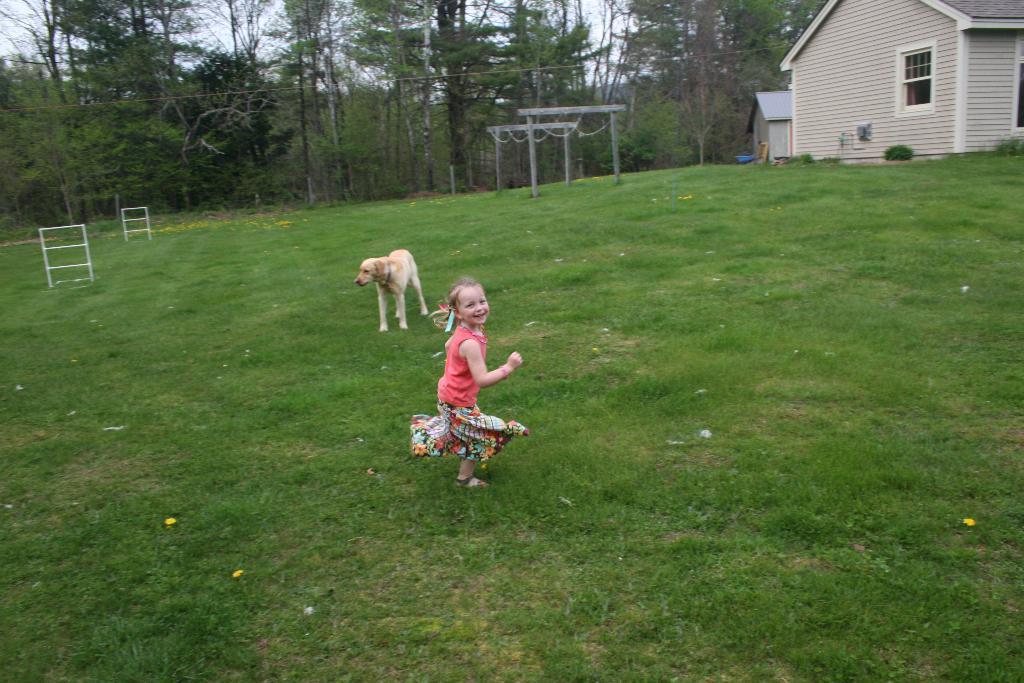In one or two sentences, can you explain what this image depicts? In this image I can see green grass ground and on it I can see a girl and a dog is standing. I can see she is wearing pink colour dress. I can also see smile on her face. In the background I can see number of trees, sky and a house. 